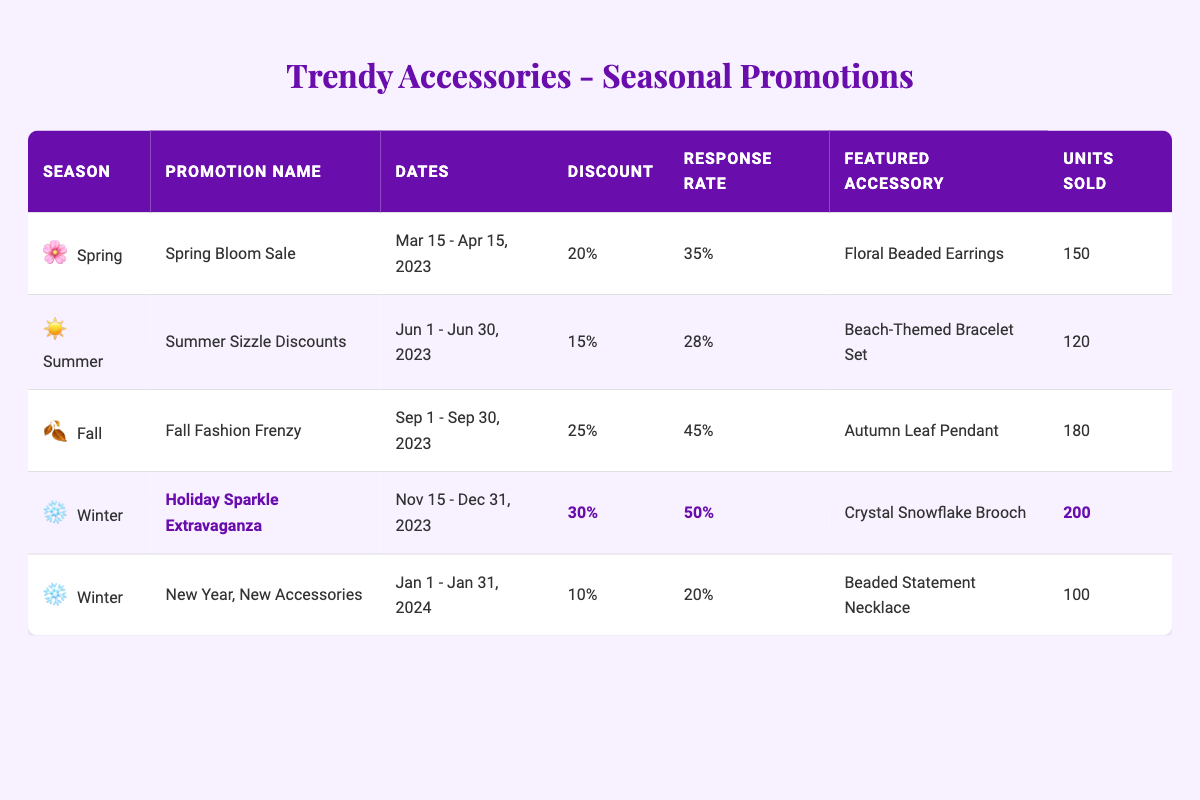What is the customer response rate for the Holiday Sparkle Extravaganza? The table lists a customer response rate of 50% for the Holiday Sparkle Extravaganza.
Answer: 50% Which featured accessory was sold the most during the Fall Fashion Frenzy promotion? The Fall Fashion Frenzy promotion shows that the featured accessory, the Autumn Leaf Pendant, had 180 units sold, which is the highest figure in the table.
Answer: Autumn Leaf Pendant What is the discount percentage for the Spring Bloom Sale? The table indicates that the discount percentage for the Spring Bloom Sale is 20%.
Answer: 20% How many units were sold during the Summer Sizzle Discounts compared to the Spring Bloom Sale? The Summer Sizzle Discounts resulted in 120 units sold, while the Spring Bloom Sale had 150 units sold. Subtracting gives 150 - 120 = 30, so 30 more units were sold during the Spring Bloom Sale.
Answer: 30 Is the response rate for the New Year, New Accessories promotion higher than the Summer Sizzle Discounts? The response rate for the New Year, New Accessories is 20%, while the Summer Sizzle Discounts has a response rate of 28%. Since 20% is less than 28%, the statement is false.
Answer: No What is the total number of units sold across all winter promotions? The winter promotions include the Holiday Sparkle Extravaganza (200 units) and New Year, New Accessories (100 units). Adding these gives 200 + 100 = 300 units sold in total for the winter.
Answer: 300 Which promotion had the highest discount percentage? The highest discount percentage in the table is 30%, noted for the Holiday Sparkle Extravaganza.
Answer: Holiday Sparkle Extravaganza What is the average customer response rate for the Spring and Summer promotions combined? The customer response rates for Spring Bloom Sale (35%) and Summer Sizzle Discounts (28%) must be added: 35 + 28 = 63, then divided by the number of promotions (2): 63 / 2 = 31.5%.
Answer: 31.5% Compare the units sold for Autumn Leaf Pendant and Beach-Themed Bracelet Set. Which one sold more? The Autumn Leaf Pendant sold 180 units, while the Beach-Themed Bracelet Set sold 120 units. Since 180 is greater than 120, the Autumn Leaf Pendant sold more.
Answer: Autumn Leaf Pendant What season corresponds to the promotion with the least units sold? The promotion with the least units sold is the New Year, New Accessories with 100 units, which is held in the Winter season.
Answer: Winter 